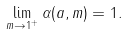Convert formula to latex. <formula><loc_0><loc_0><loc_500><loc_500>\lim _ { m \to 1 ^ { + } } \alpha ( a , m ) = 1 .</formula> 